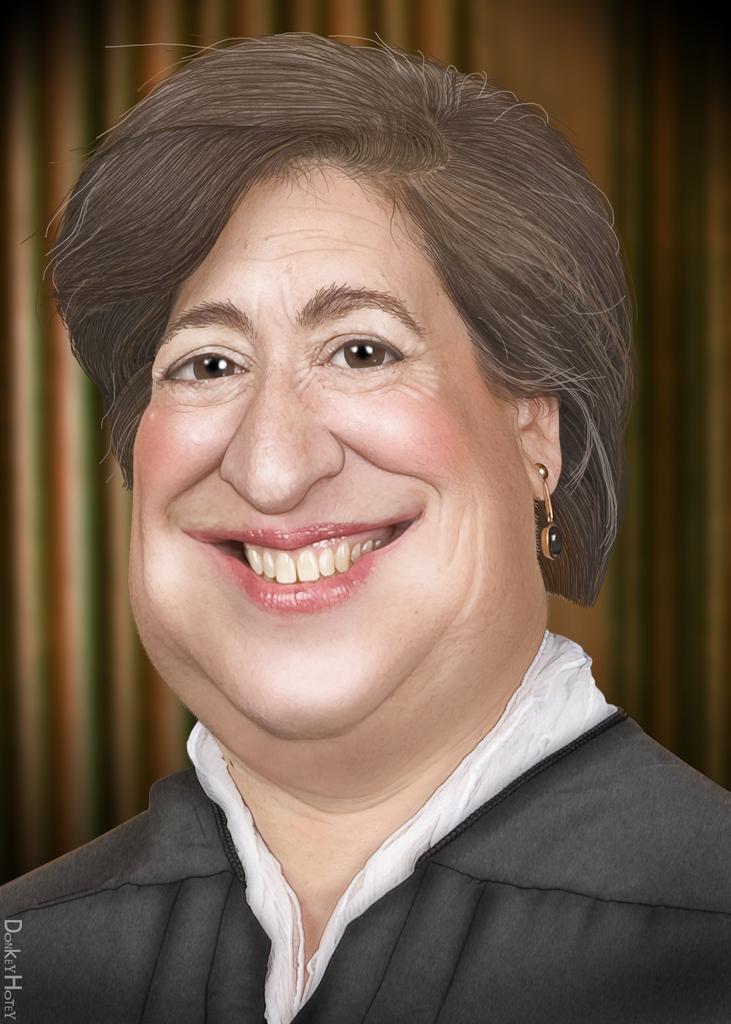Describe this image in one or two sentences. In the picture I can see an image of a woman smiling and there is something written in the left corner. 